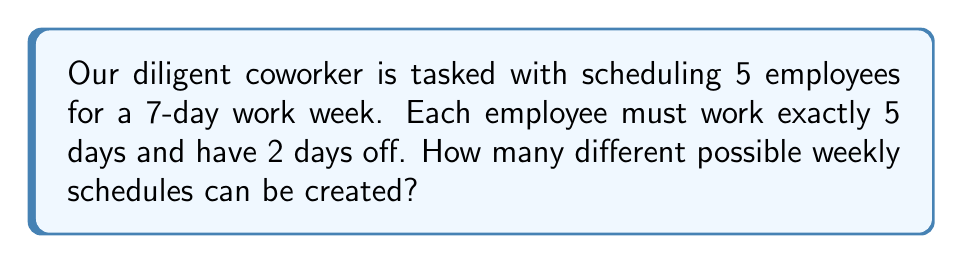Teach me how to tackle this problem. Let's approach this step-by-step:

1) For each employee, we need to choose 2 days off out of 7 days.

2) This is equivalent to choosing 2 items from a set of 7, which is a combination problem.

3) The number of ways to choose 2 days off for one employee is given by the combination formula:

   $$\binom{7}{2} = \frac{7!}{2!(7-2)!} = \frac{7!}{2!(5)!} = \frac{7 \cdot 6}{2 \cdot 1} = 21$$

4) Now, we need to do this for all 5 employees independently.

5) According to the multiplication principle, if we have 21 choices for each of the 5 employees, the total number of possible schedules is:

   $$21 \cdot 21 \cdot 21 \cdot 21 \cdot 21 = 21^5$$

6) Calculate:
   $$21^5 = 4,084,101$$

Therefore, there are 4,084,101 different possible weekly schedules.
Answer: $21^5 = 4,084,101$ 